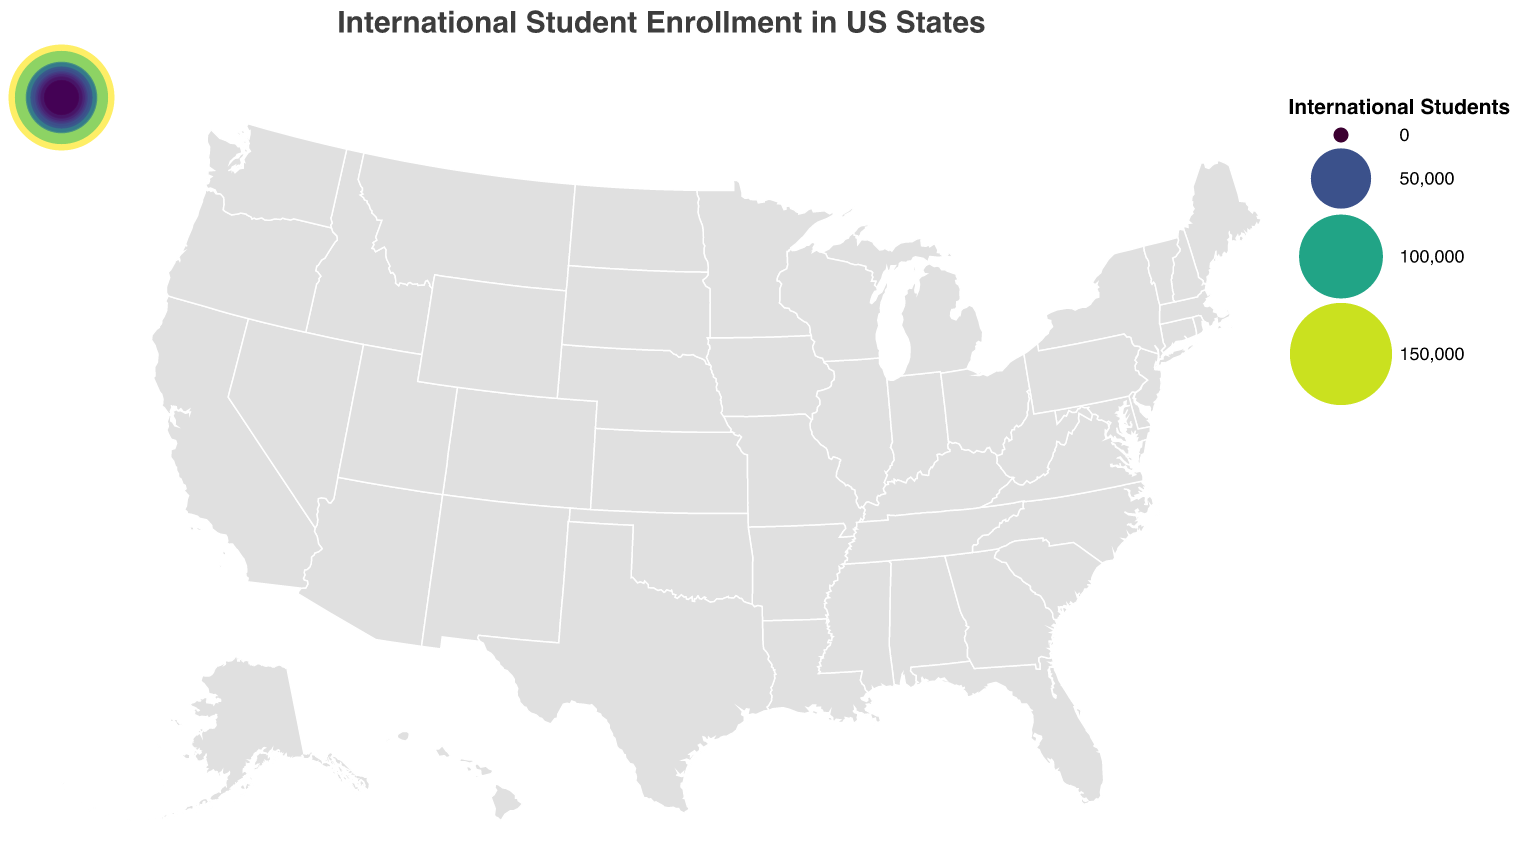Which state has the highest international student enrollment? Look at the state with the largest circle and the highest data point. California has the most significant number of international students.
Answer: California Which state has the second-highest number of international students? Identify the state with the second-largest circle. New York comes after California in terms of student count.
Answer: New York How many more international students are in California compared to Texas? Subtract the number of students in Texas from that in California: 161,693 - 67,428.
Answer: 94,265 What is the total enrollment of international students in California, New York, and Massachusetts combined? Add the enrollment numbers for California, New York, and Massachusetts: 161,693 + 124,277 + 71,992.
Answer: 357,962 Which states have an international student population between 20,000 and 30,000? Identify the states with student counts within that range: Indiana, Washington, New Jersey, Arizona, Georgia, Virginia, North Carolina.
Answer: Indiana, Washington, New Jersey, Arizona, Georgia, Virginia, North Carolina What is the average number of international students in the top five states? Add the student numbers for the top five states and divide by five: (161,693 + 124,277 + 71,992 + 67,428 + 53,724) / 5.
Answer: 95,022.8 Which state has more international students, Florida or Ohio? Compare the student numbers for Florida and Ohio. Florida has 45,957 students, and Ohio has 37,314.
Answer: Florida What is the total number of international students in all listed states? Sum up the enrollment numbers for all states: 161,693 + 124,277 + 71,992 + 67,428 + 53,724 + 51,818 + 45,957 + 37,314 + 33,236 + 29,083 + 27,915 + 23,456 + 22,520 + 21,843 + 20,999 + 20,663 + 15,078 + 14,673 + 14,202 + 13,335.
Answer: 923,204 Which state listed last in the data has the fewest international students per the plot? Refer to the last state in the data provided: Colorado has the lowest number compared to others listed.
Answer: Colorado 